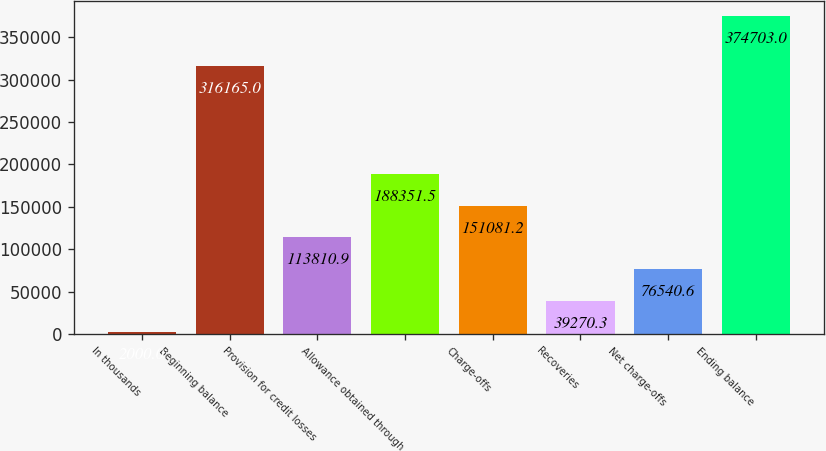<chart> <loc_0><loc_0><loc_500><loc_500><bar_chart><fcel>In thousands<fcel>Beginning balance<fcel>Provision for credit losses<fcel>Allowance obtained through<fcel>Charge-offs<fcel>Recoveries<fcel>Net charge-offs<fcel>Ending balance<nl><fcel>2000<fcel>316165<fcel>113811<fcel>188352<fcel>151081<fcel>39270.3<fcel>76540.6<fcel>374703<nl></chart> 